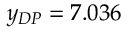Convert formula to latex. <formula><loc_0><loc_0><loc_500><loc_500>y _ { D P } = 7 . 0 3 6</formula> 